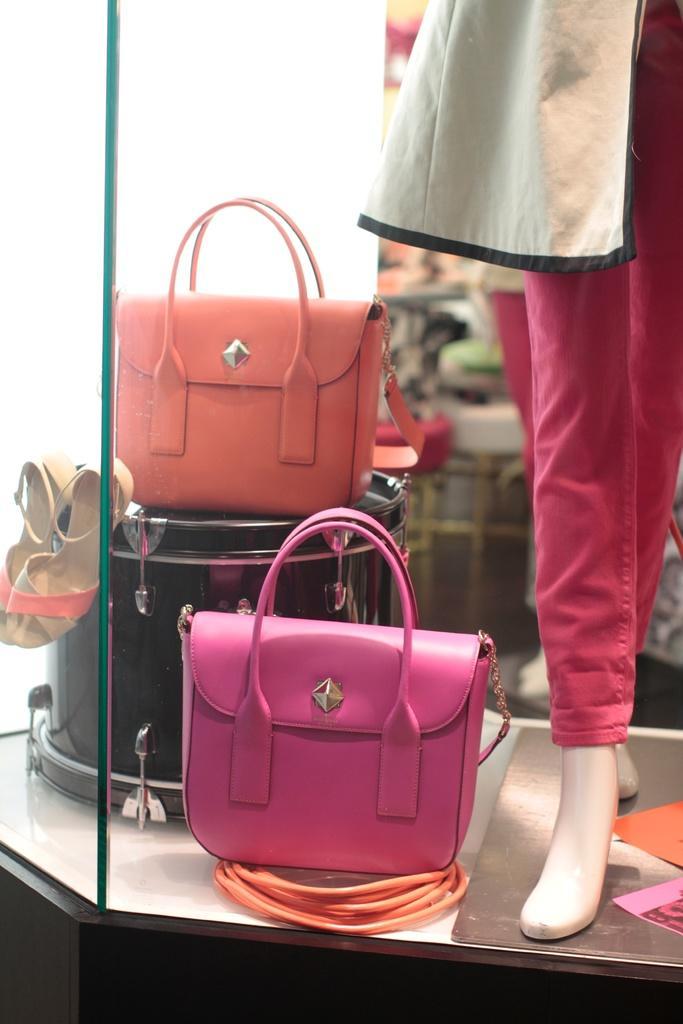Could you give a brief overview of what you see in this image? there is a pink handbag. behind that there is a orange hand bag and a pair of sandles. on the right there is a mannequin which is wearing a pink pant. 